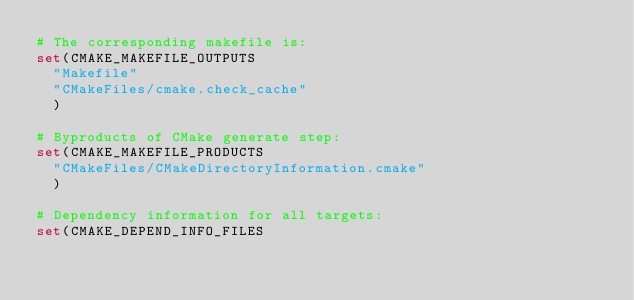Convert code to text. <code><loc_0><loc_0><loc_500><loc_500><_CMake_># The corresponding makefile is:
set(CMAKE_MAKEFILE_OUTPUTS
  "Makefile"
  "CMakeFiles/cmake.check_cache"
  )

# Byproducts of CMake generate step:
set(CMAKE_MAKEFILE_PRODUCTS
  "CMakeFiles/CMakeDirectoryInformation.cmake"
  )

# Dependency information for all targets:
set(CMAKE_DEPEND_INFO_FILES</code> 